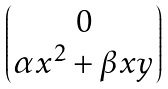<formula> <loc_0><loc_0><loc_500><loc_500>\begin{pmatrix} 0 \\ \alpha x ^ { 2 } + \beta x y \end{pmatrix}</formula> 